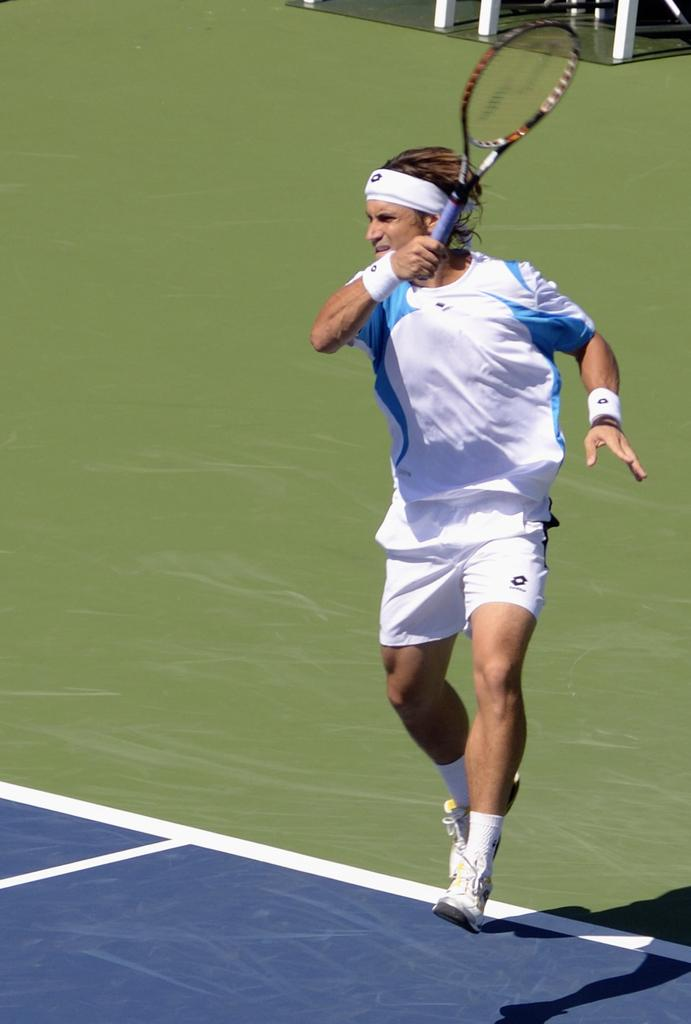What is the man in the image doing? The man is playing badminton. What object is the man holding in the image? The man is holding a bat. What accessory is the man wearing in the image? The man is wearing a wrist band. What type of ear is visible on the man in the image? There is no ear visible on the man in the image; only his face, badminton bat, and wrist band are shown. 